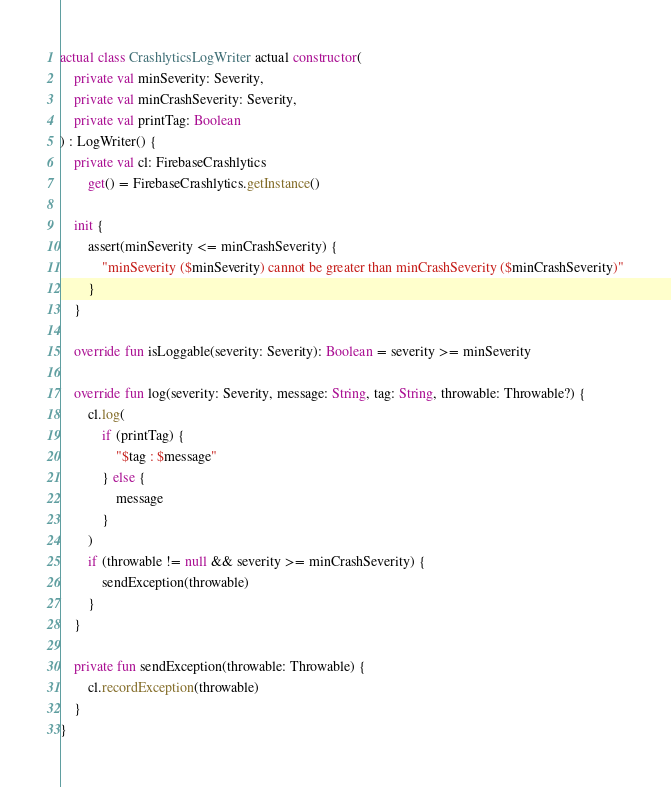Convert code to text. <code><loc_0><loc_0><loc_500><loc_500><_Kotlin_>actual class CrashlyticsLogWriter actual constructor(
    private val minSeverity: Severity,
    private val minCrashSeverity: Severity,
    private val printTag: Boolean
) : LogWriter() {
    private val cl: FirebaseCrashlytics
        get() = FirebaseCrashlytics.getInstance()

    init {
        assert(minSeverity <= minCrashSeverity) {
            "minSeverity ($minSeverity) cannot be greater than minCrashSeverity ($minCrashSeverity)"
        }
    }

    override fun isLoggable(severity: Severity): Boolean = severity >= minSeverity

    override fun log(severity: Severity, message: String, tag: String, throwable: Throwable?) {
        cl.log(
            if (printTag) {
                "$tag : $message"
            } else {
                message
            }
        )
        if (throwable != null && severity >= minCrashSeverity) {
            sendException(throwable)
        }
    }

    private fun sendException(throwable: Throwable) {
        cl.recordException(throwable)
    }
}</code> 